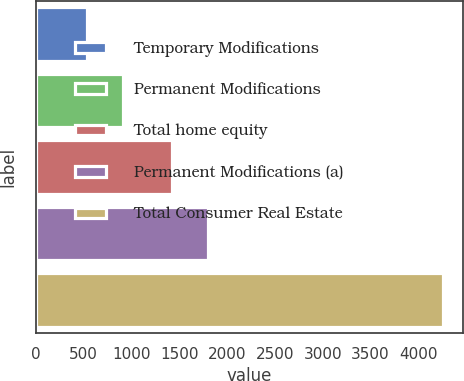<chart> <loc_0><loc_0><loc_500><loc_500><bar_chart><fcel>Temporary Modifications<fcel>Permanent Modifications<fcel>Total home equity<fcel>Permanent Modifications (a)<fcel>Total Consumer Real Estate<nl><fcel>539<fcel>910.8<fcel>1428<fcel>1799.8<fcel>4257<nl></chart> 